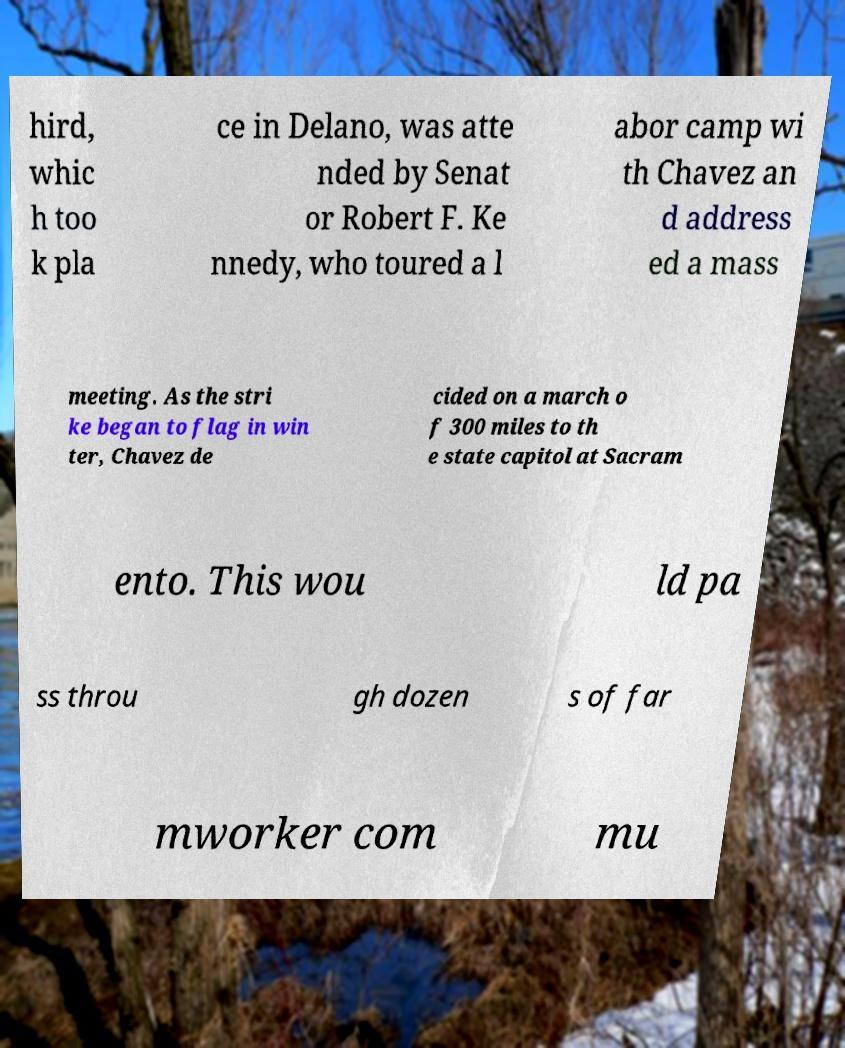Could you extract and type out the text from this image? hird, whic h too k pla ce in Delano, was atte nded by Senat or Robert F. Ke nnedy, who toured a l abor camp wi th Chavez an d address ed a mass meeting. As the stri ke began to flag in win ter, Chavez de cided on a march o f 300 miles to th e state capitol at Sacram ento. This wou ld pa ss throu gh dozen s of far mworker com mu 